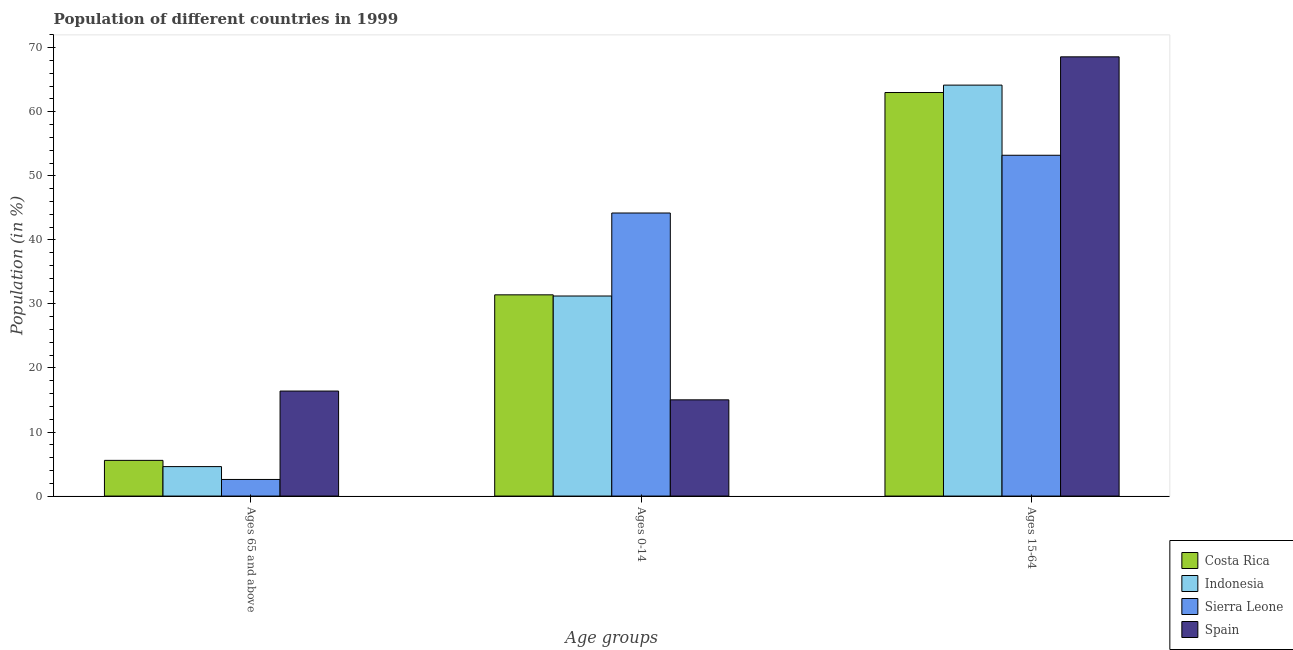How many different coloured bars are there?
Your answer should be very brief. 4. Are the number of bars per tick equal to the number of legend labels?
Ensure brevity in your answer.  Yes. Are the number of bars on each tick of the X-axis equal?
Ensure brevity in your answer.  Yes. What is the label of the 3rd group of bars from the left?
Keep it short and to the point. Ages 15-64. What is the percentage of population within the age-group of 65 and above in Costa Rica?
Provide a short and direct response. 5.57. Across all countries, what is the maximum percentage of population within the age-group 15-64?
Offer a very short reply. 68.58. Across all countries, what is the minimum percentage of population within the age-group 15-64?
Provide a short and direct response. 53.21. In which country was the percentage of population within the age-group of 65 and above maximum?
Your response must be concise. Spain. In which country was the percentage of population within the age-group of 65 and above minimum?
Keep it short and to the point. Sierra Leone. What is the total percentage of population within the age-group of 65 and above in the graph?
Give a very brief answer. 29.16. What is the difference between the percentage of population within the age-group 0-14 in Indonesia and that in Spain?
Your answer should be compact. 16.21. What is the difference between the percentage of population within the age-group of 65 and above in Costa Rica and the percentage of population within the age-group 0-14 in Sierra Leone?
Provide a succinct answer. -38.62. What is the average percentage of population within the age-group 0-14 per country?
Make the answer very short. 30.47. What is the difference between the percentage of population within the age-group 15-64 and percentage of population within the age-group 0-14 in Costa Rica?
Provide a short and direct response. 31.59. In how many countries, is the percentage of population within the age-group of 65 and above greater than 24 %?
Your answer should be very brief. 0. What is the ratio of the percentage of population within the age-group of 65 and above in Sierra Leone to that in Costa Rica?
Your answer should be compact. 0.47. Is the difference between the percentage of population within the age-group 15-64 in Spain and Indonesia greater than the difference between the percentage of population within the age-group of 65 and above in Spain and Indonesia?
Keep it short and to the point. No. What is the difference between the highest and the second highest percentage of population within the age-group 0-14?
Keep it short and to the point. 12.78. What is the difference between the highest and the lowest percentage of population within the age-group 15-64?
Keep it short and to the point. 15.37. In how many countries, is the percentage of population within the age-group 15-64 greater than the average percentage of population within the age-group 15-64 taken over all countries?
Ensure brevity in your answer.  3. Is the sum of the percentage of population within the age-group of 65 and above in Costa Rica and Spain greater than the maximum percentage of population within the age-group 15-64 across all countries?
Keep it short and to the point. No. What does the 1st bar from the right in Ages 0-14 represents?
Your answer should be very brief. Spain. How many bars are there?
Offer a terse response. 12. What is the difference between two consecutive major ticks on the Y-axis?
Ensure brevity in your answer.  10. Are the values on the major ticks of Y-axis written in scientific E-notation?
Offer a very short reply. No. Where does the legend appear in the graph?
Offer a terse response. Bottom right. How many legend labels are there?
Offer a very short reply. 4. How are the legend labels stacked?
Provide a succinct answer. Vertical. What is the title of the graph?
Give a very brief answer. Population of different countries in 1999. What is the label or title of the X-axis?
Ensure brevity in your answer.  Age groups. What is the Population (in %) of Costa Rica in Ages 65 and above?
Ensure brevity in your answer.  5.57. What is the Population (in %) in Indonesia in Ages 65 and above?
Offer a very short reply. 4.6. What is the Population (in %) of Sierra Leone in Ages 65 and above?
Your answer should be compact. 2.59. What is the Population (in %) of Spain in Ages 65 and above?
Give a very brief answer. 16.4. What is the Population (in %) in Costa Rica in Ages 0-14?
Your answer should be very brief. 31.42. What is the Population (in %) in Indonesia in Ages 0-14?
Provide a short and direct response. 31.24. What is the Population (in %) in Sierra Leone in Ages 0-14?
Keep it short and to the point. 44.19. What is the Population (in %) in Spain in Ages 0-14?
Provide a succinct answer. 15.02. What is the Population (in %) of Costa Rica in Ages 15-64?
Provide a short and direct response. 63.01. What is the Population (in %) in Indonesia in Ages 15-64?
Make the answer very short. 64.16. What is the Population (in %) of Sierra Leone in Ages 15-64?
Provide a succinct answer. 53.21. What is the Population (in %) of Spain in Ages 15-64?
Give a very brief answer. 68.58. Across all Age groups, what is the maximum Population (in %) in Costa Rica?
Provide a short and direct response. 63.01. Across all Age groups, what is the maximum Population (in %) of Indonesia?
Your answer should be compact. 64.16. Across all Age groups, what is the maximum Population (in %) in Sierra Leone?
Offer a very short reply. 53.21. Across all Age groups, what is the maximum Population (in %) of Spain?
Offer a very short reply. 68.58. Across all Age groups, what is the minimum Population (in %) in Costa Rica?
Your answer should be very brief. 5.57. Across all Age groups, what is the minimum Population (in %) in Indonesia?
Offer a terse response. 4.6. Across all Age groups, what is the minimum Population (in %) in Sierra Leone?
Ensure brevity in your answer.  2.59. Across all Age groups, what is the minimum Population (in %) of Spain?
Keep it short and to the point. 15.02. What is the total Population (in %) of Costa Rica in the graph?
Give a very brief answer. 100. What is the total Population (in %) of Spain in the graph?
Your answer should be compact. 100. What is the difference between the Population (in %) in Costa Rica in Ages 65 and above and that in Ages 0-14?
Offer a very short reply. -25.85. What is the difference between the Population (in %) in Indonesia in Ages 65 and above and that in Ages 0-14?
Make the answer very short. -26.64. What is the difference between the Population (in %) in Sierra Leone in Ages 65 and above and that in Ages 0-14?
Offer a terse response. -41.6. What is the difference between the Population (in %) in Spain in Ages 65 and above and that in Ages 0-14?
Give a very brief answer. 1.37. What is the difference between the Population (in %) of Costa Rica in Ages 65 and above and that in Ages 15-64?
Keep it short and to the point. -57.43. What is the difference between the Population (in %) of Indonesia in Ages 65 and above and that in Ages 15-64?
Offer a terse response. -59.57. What is the difference between the Population (in %) of Sierra Leone in Ages 65 and above and that in Ages 15-64?
Offer a very short reply. -50.62. What is the difference between the Population (in %) of Spain in Ages 65 and above and that in Ages 15-64?
Your answer should be compact. -52.18. What is the difference between the Population (in %) in Costa Rica in Ages 0-14 and that in Ages 15-64?
Ensure brevity in your answer.  -31.59. What is the difference between the Population (in %) of Indonesia in Ages 0-14 and that in Ages 15-64?
Your response must be concise. -32.93. What is the difference between the Population (in %) in Sierra Leone in Ages 0-14 and that in Ages 15-64?
Provide a succinct answer. -9.02. What is the difference between the Population (in %) of Spain in Ages 0-14 and that in Ages 15-64?
Your answer should be compact. -53.56. What is the difference between the Population (in %) of Costa Rica in Ages 65 and above and the Population (in %) of Indonesia in Ages 0-14?
Keep it short and to the point. -25.66. What is the difference between the Population (in %) in Costa Rica in Ages 65 and above and the Population (in %) in Sierra Leone in Ages 0-14?
Provide a short and direct response. -38.62. What is the difference between the Population (in %) of Costa Rica in Ages 65 and above and the Population (in %) of Spain in Ages 0-14?
Give a very brief answer. -9.45. What is the difference between the Population (in %) of Indonesia in Ages 65 and above and the Population (in %) of Sierra Leone in Ages 0-14?
Give a very brief answer. -39.59. What is the difference between the Population (in %) of Indonesia in Ages 65 and above and the Population (in %) of Spain in Ages 0-14?
Give a very brief answer. -10.42. What is the difference between the Population (in %) in Sierra Leone in Ages 65 and above and the Population (in %) in Spain in Ages 0-14?
Make the answer very short. -12.43. What is the difference between the Population (in %) of Costa Rica in Ages 65 and above and the Population (in %) of Indonesia in Ages 15-64?
Offer a very short reply. -58.59. What is the difference between the Population (in %) in Costa Rica in Ages 65 and above and the Population (in %) in Sierra Leone in Ages 15-64?
Your response must be concise. -47.64. What is the difference between the Population (in %) of Costa Rica in Ages 65 and above and the Population (in %) of Spain in Ages 15-64?
Provide a short and direct response. -63.01. What is the difference between the Population (in %) in Indonesia in Ages 65 and above and the Population (in %) in Sierra Leone in Ages 15-64?
Your answer should be very brief. -48.61. What is the difference between the Population (in %) in Indonesia in Ages 65 and above and the Population (in %) in Spain in Ages 15-64?
Your answer should be very brief. -63.98. What is the difference between the Population (in %) of Sierra Leone in Ages 65 and above and the Population (in %) of Spain in Ages 15-64?
Provide a short and direct response. -65.99. What is the difference between the Population (in %) in Costa Rica in Ages 0-14 and the Population (in %) in Indonesia in Ages 15-64?
Your response must be concise. -32.75. What is the difference between the Population (in %) of Costa Rica in Ages 0-14 and the Population (in %) of Sierra Leone in Ages 15-64?
Your answer should be very brief. -21.79. What is the difference between the Population (in %) of Costa Rica in Ages 0-14 and the Population (in %) of Spain in Ages 15-64?
Provide a succinct answer. -37.16. What is the difference between the Population (in %) in Indonesia in Ages 0-14 and the Population (in %) in Sierra Leone in Ages 15-64?
Offer a terse response. -21.98. What is the difference between the Population (in %) of Indonesia in Ages 0-14 and the Population (in %) of Spain in Ages 15-64?
Your answer should be compact. -37.34. What is the difference between the Population (in %) of Sierra Leone in Ages 0-14 and the Population (in %) of Spain in Ages 15-64?
Make the answer very short. -24.39. What is the average Population (in %) of Costa Rica per Age groups?
Ensure brevity in your answer.  33.33. What is the average Population (in %) in Indonesia per Age groups?
Your answer should be compact. 33.33. What is the average Population (in %) in Sierra Leone per Age groups?
Provide a succinct answer. 33.33. What is the average Population (in %) in Spain per Age groups?
Provide a short and direct response. 33.33. What is the difference between the Population (in %) in Costa Rica and Population (in %) in Sierra Leone in Ages 65 and above?
Provide a short and direct response. 2.98. What is the difference between the Population (in %) of Costa Rica and Population (in %) of Spain in Ages 65 and above?
Offer a terse response. -10.82. What is the difference between the Population (in %) in Indonesia and Population (in %) in Sierra Leone in Ages 65 and above?
Your response must be concise. 2.01. What is the difference between the Population (in %) of Indonesia and Population (in %) of Spain in Ages 65 and above?
Ensure brevity in your answer.  -11.8. What is the difference between the Population (in %) in Sierra Leone and Population (in %) in Spain in Ages 65 and above?
Provide a succinct answer. -13.8. What is the difference between the Population (in %) in Costa Rica and Population (in %) in Indonesia in Ages 0-14?
Offer a terse response. 0.18. What is the difference between the Population (in %) in Costa Rica and Population (in %) in Sierra Leone in Ages 0-14?
Your response must be concise. -12.78. What is the difference between the Population (in %) in Costa Rica and Population (in %) in Spain in Ages 0-14?
Provide a short and direct response. 16.4. What is the difference between the Population (in %) of Indonesia and Population (in %) of Sierra Leone in Ages 0-14?
Ensure brevity in your answer.  -12.96. What is the difference between the Population (in %) of Indonesia and Population (in %) of Spain in Ages 0-14?
Provide a succinct answer. 16.21. What is the difference between the Population (in %) of Sierra Leone and Population (in %) of Spain in Ages 0-14?
Offer a very short reply. 29.17. What is the difference between the Population (in %) in Costa Rica and Population (in %) in Indonesia in Ages 15-64?
Make the answer very short. -1.16. What is the difference between the Population (in %) in Costa Rica and Population (in %) in Sierra Leone in Ages 15-64?
Keep it short and to the point. 9.79. What is the difference between the Population (in %) of Costa Rica and Population (in %) of Spain in Ages 15-64?
Offer a terse response. -5.57. What is the difference between the Population (in %) in Indonesia and Population (in %) in Sierra Leone in Ages 15-64?
Keep it short and to the point. 10.95. What is the difference between the Population (in %) in Indonesia and Population (in %) in Spain in Ages 15-64?
Your response must be concise. -4.41. What is the difference between the Population (in %) of Sierra Leone and Population (in %) of Spain in Ages 15-64?
Your answer should be compact. -15.37. What is the ratio of the Population (in %) of Costa Rica in Ages 65 and above to that in Ages 0-14?
Your answer should be compact. 0.18. What is the ratio of the Population (in %) in Indonesia in Ages 65 and above to that in Ages 0-14?
Make the answer very short. 0.15. What is the ratio of the Population (in %) in Sierra Leone in Ages 65 and above to that in Ages 0-14?
Keep it short and to the point. 0.06. What is the ratio of the Population (in %) in Spain in Ages 65 and above to that in Ages 0-14?
Your answer should be very brief. 1.09. What is the ratio of the Population (in %) in Costa Rica in Ages 65 and above to that in Ages 15-64?
Your response must be concise. 0.09. What is the ratio of the Population (in %) of Indonesia in Ages 65 and above to that in Ages 15-64?
Your answer should be compact. 0.07. What is the ratio of the Population (in %) of Sierra Leone in Ages 65 and above to that in Ages 15-64?
Ensure brevity in your answer.  0.05. What is the ratio of the Population (in %) of Spain in Ages 65 and above to that in Ages 15-64?
Ensure brevity in your answer.  0.24. What is the ratio of the Population (in %) of Costa Rica in Ages 0-14 to that in Ages 15-64?
Offer a very short reply. 0.5. What is the ratio of the Population (in %) in Indonesia in Ages 0-14 to that in Ages 15-64?
Provide a succinct answer. 0.49. What is the ratio of the Population (in %) in Sierra Leone in Ages 0-14 to that in Ages 15-64?
Give a very brief answer. 0.83. What is the ratio of the Population (in %) in Spain in Ages 0-14 to that in Ages 15-64?
Give a very brief answer. 0.22. What is the difference between the highest and the second highest Population (in %) in Costa Rica?
Ensure brevity in your answer.  31.59. What is the difference between the highest and the second highest Population (in %) in Indonesia?
Your answer should be compact. 32.93. What is the difference between the highest and the second highest Population (in %) in Sierra Leone?
Make the answer very short. 9.02. What is the difference between the highest and the second highest Population (in %) of Spain?
Offer a very short reply. 52.18. What is the difference between the highest and the lowest Population (in %) in Costa Rica?
Make the answer very short. 57.43. What is the difference between the highest and the lowest Population (in %) in Indonesia?
Provide a succinct answer. 59.57. What is the difference between the highest and the lowest Population (in %) in Sierra Leone?
Provide a short and direct response. 50.62. What is the difference between the highest and the lowest Population (in %) of Spain?
Ensure brevity in your answer.  53.56. 